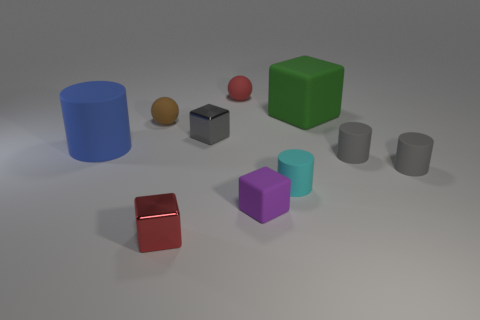Subtract all small cylinders. How many cylinders are left? 1 Subtract all brown balls. How many balls are left? 1 Subtract 4 cylinders. How many cylinders are left? 0 Subtract all cubes. How many objects are left? 6 Subtract all yellow cylinders. How many brown balls are left? 1 Add 4 red things. How many red things are left? 6 Add 10 blue rubber spheres. How many blue rubber spheres exist? 10 Subtract 0 red cylinders. How many objects are left? 10 Subtract all brown blocks. Subtract all yellow spheres. How many blocks are left? 4 Subtract all tiny purple things. Subtract all big blue objects. How many objects are left? 8 